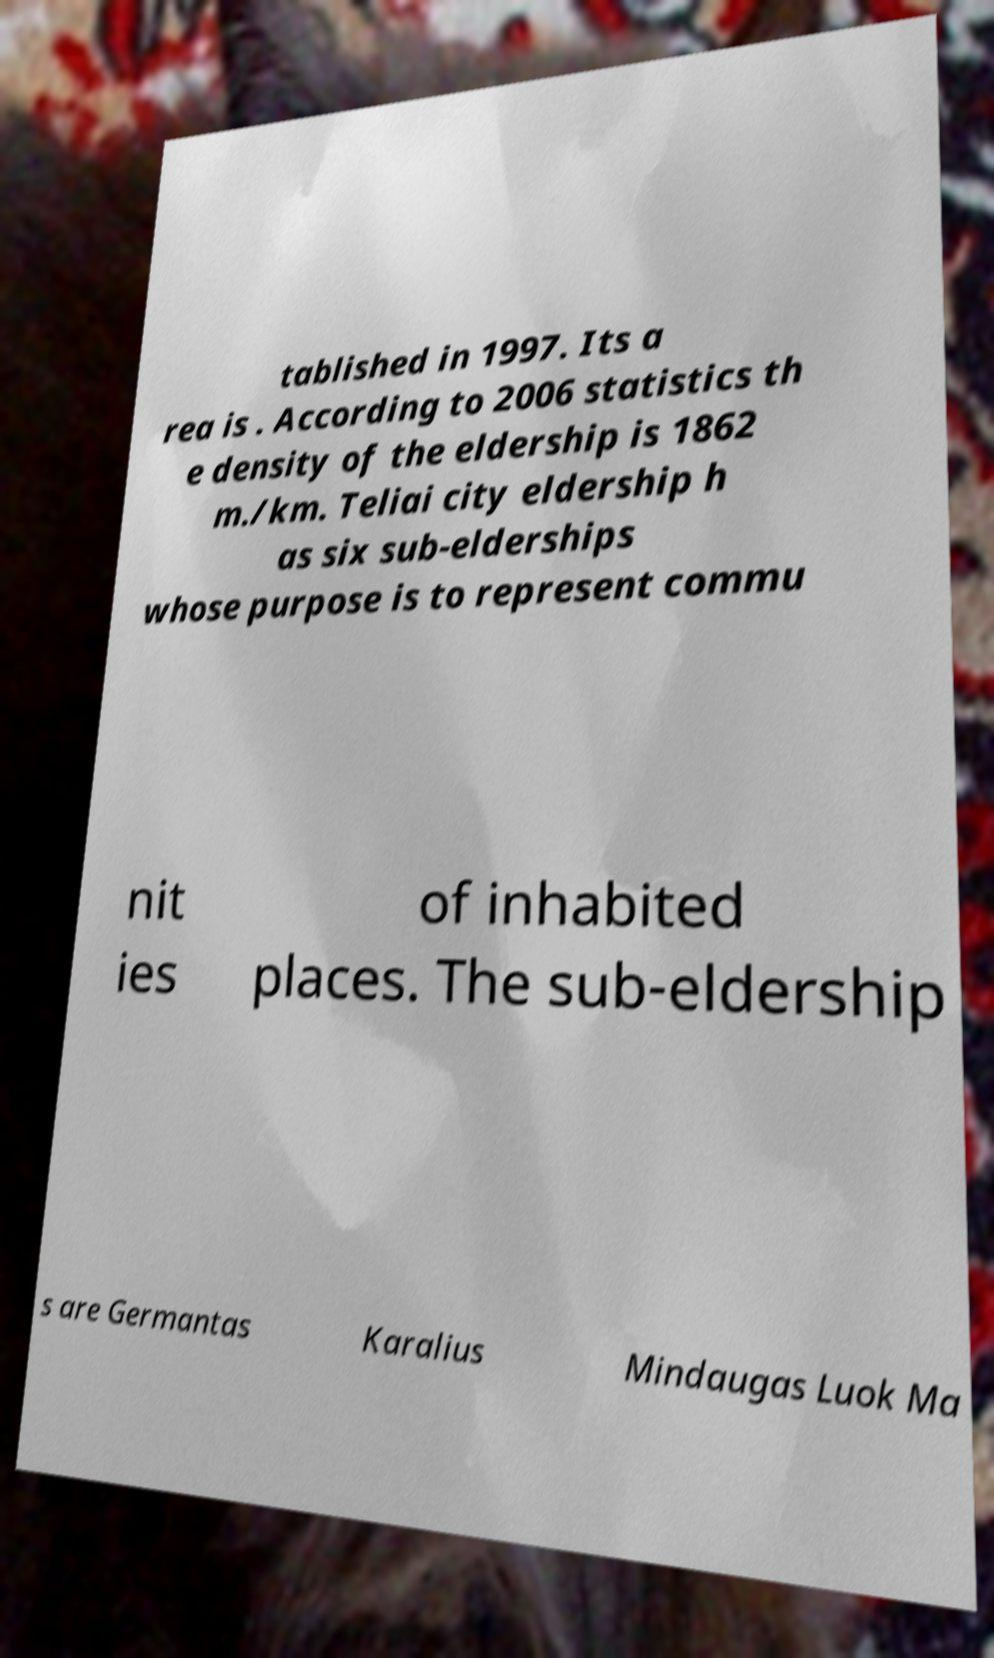Could you assist in decoding the text presented in this image and type it out clearly? tablished in 1997. Its a rea is . According to 2006 statistics th e density of the eldership is 1862 m./km. Teliai city eldership h as six sub-elderships whose purpose is to represent commu nit ies of inhabited places. The sub-eldership s are Germantas Karalius Mindaugas Luok Ma 